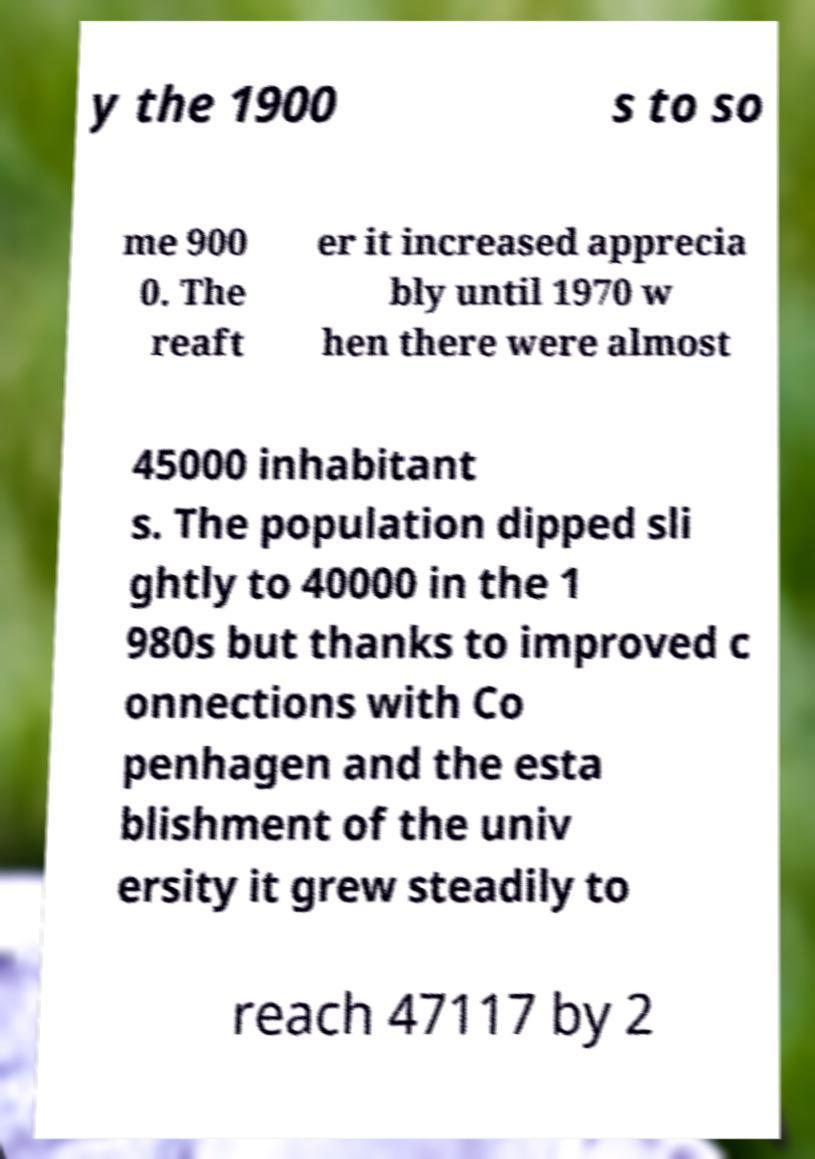Can you read and provide the text displayed in the image?This photo seems to have some interesting text. Can you extract and type it out for me? y the 1900 s to so me 900 0. The reaft er it increased apprecia bly until 1970 w hen there were almost 45000 inhabitant s. The population dipped sli ghtly to 40000 in the 1 980s but thanks to improved c onnections with Co penhagen and the esta blishment of the univ ersity it grew steadily to reach 47117 by 2 